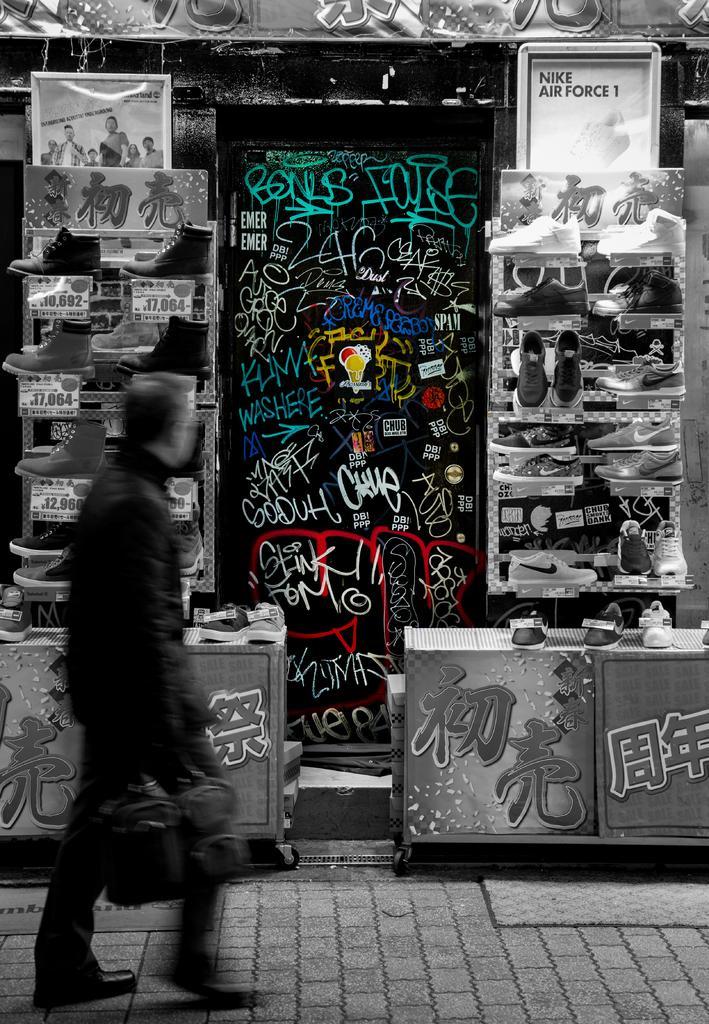Could you give a brief overview of what you see in this image? In this image we can see a man is standing on the pavement. He is holding a bag in his hand. In the background, we can see banners, tables and shoes with the tags. 